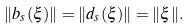<formula> <loc_0><loc_0><loc_500><loc_500>\| b _ { s } ( \xi ) \| = \| d _ { s } ( \xi ) \| = \| \xi \| .</formula> 